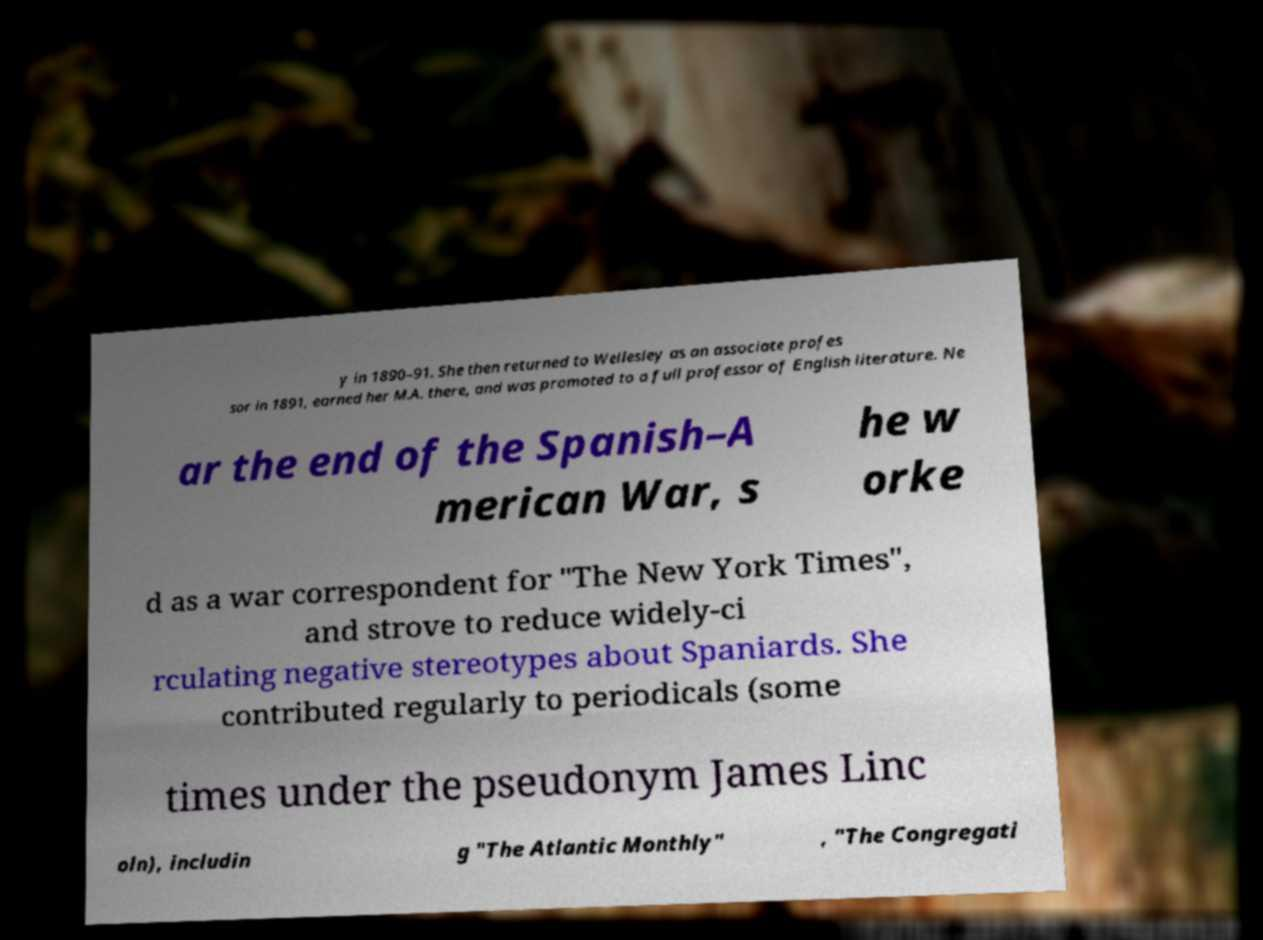Can you read and provide the text displayed in the image?This photo seems to have some interesting text. Can you extract and type it out for me? y in 1890–91. She then returned to Wellesley as an associate profes sor in 1891, earned her M.A. there, and was promoted to a full professor of English literature. Ne ar the end of the Spanish–A merican War, s he w orke d as a war correspondent for "The New York Times", and strove to reduce widely-ci rculating negative stereotypes about Spaniards. She contributed regularly to periodicals (some times under the pseudonym James Linc oln), includin g "The Atlantic Monthly" , "The Congregati 